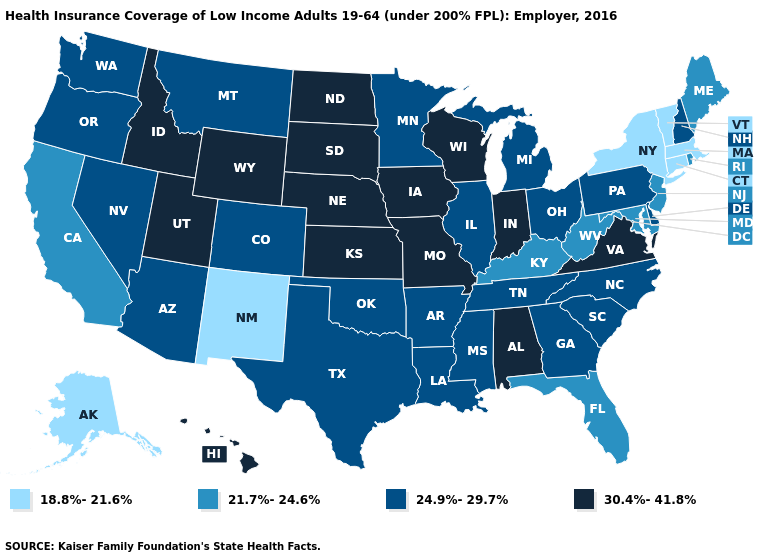Does Connecticut have the lowest value in the Northeast?
Write a very short answer. Yes. What is the lowest value in states that border Minnesota?
Short answer required. 30.4%-41.8%. Which states have the lowest value in the USA?
Write a very short answer. Alaska, Connecticut, Massachusetts, New Mexico, New York, Vermont. Does the first symbol in the legend represent the smallest category?
Answer briefly. Yes. Does Georgia have a lower value than Indiana?
Give a very brief answer. Yes. Name the states that have a value in the range 21.7%-24.6%?
Quick response, please. California, Florida, Kentucky, Maine, Maryland, New Jersey, Rhode Island, West Virginia. Which states hav the highest value in the Northeast?
Answer briefly. New Hampshire, Pennsylvania. What is the value of Vermont?
Concise answer only. 18.8%-21.6%. Does Washington have a higher value than North Dakota?
Give a very brief answer. No. Among the states that border Florida , which have the highest value?
Keep it brief. Alabama. What is the value of Iowa?
Give a very brief answer. 30.4%-41.8%. Which states have the lowest value in the USA?
Answer briefly. Alaska, Connecticut, Massachusetts, New Mexico, New York, Vermont. Which states have the lowest value in the MidWest?
Concise answer only. Illinois, Michigan, Minnesota, Ohio. Does Michigan have the highest value in the MidWest?
Answer briefly. No. What is the value of Florida?
Answer briefly. 21.7%-24.6%. 